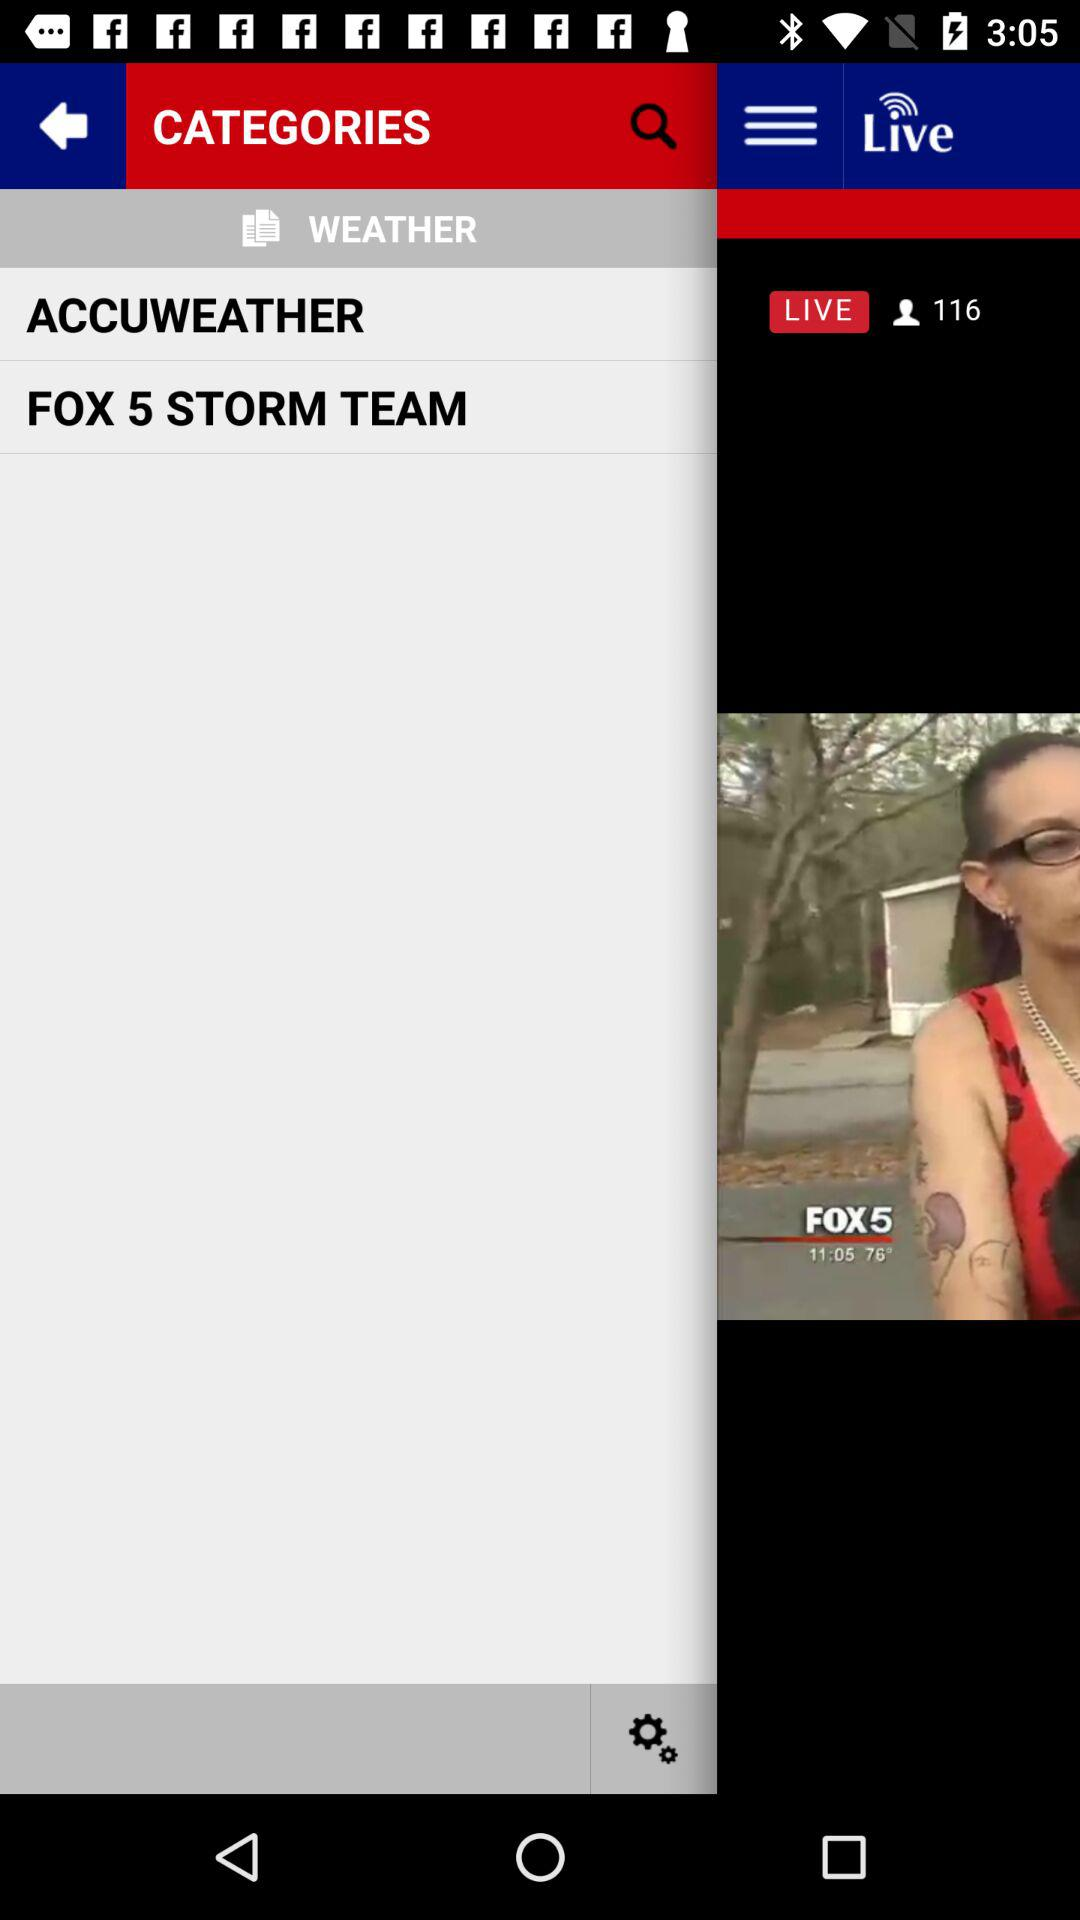When was the article posted? The article was posted on March 30, 2017 at 1:41 a.m. 